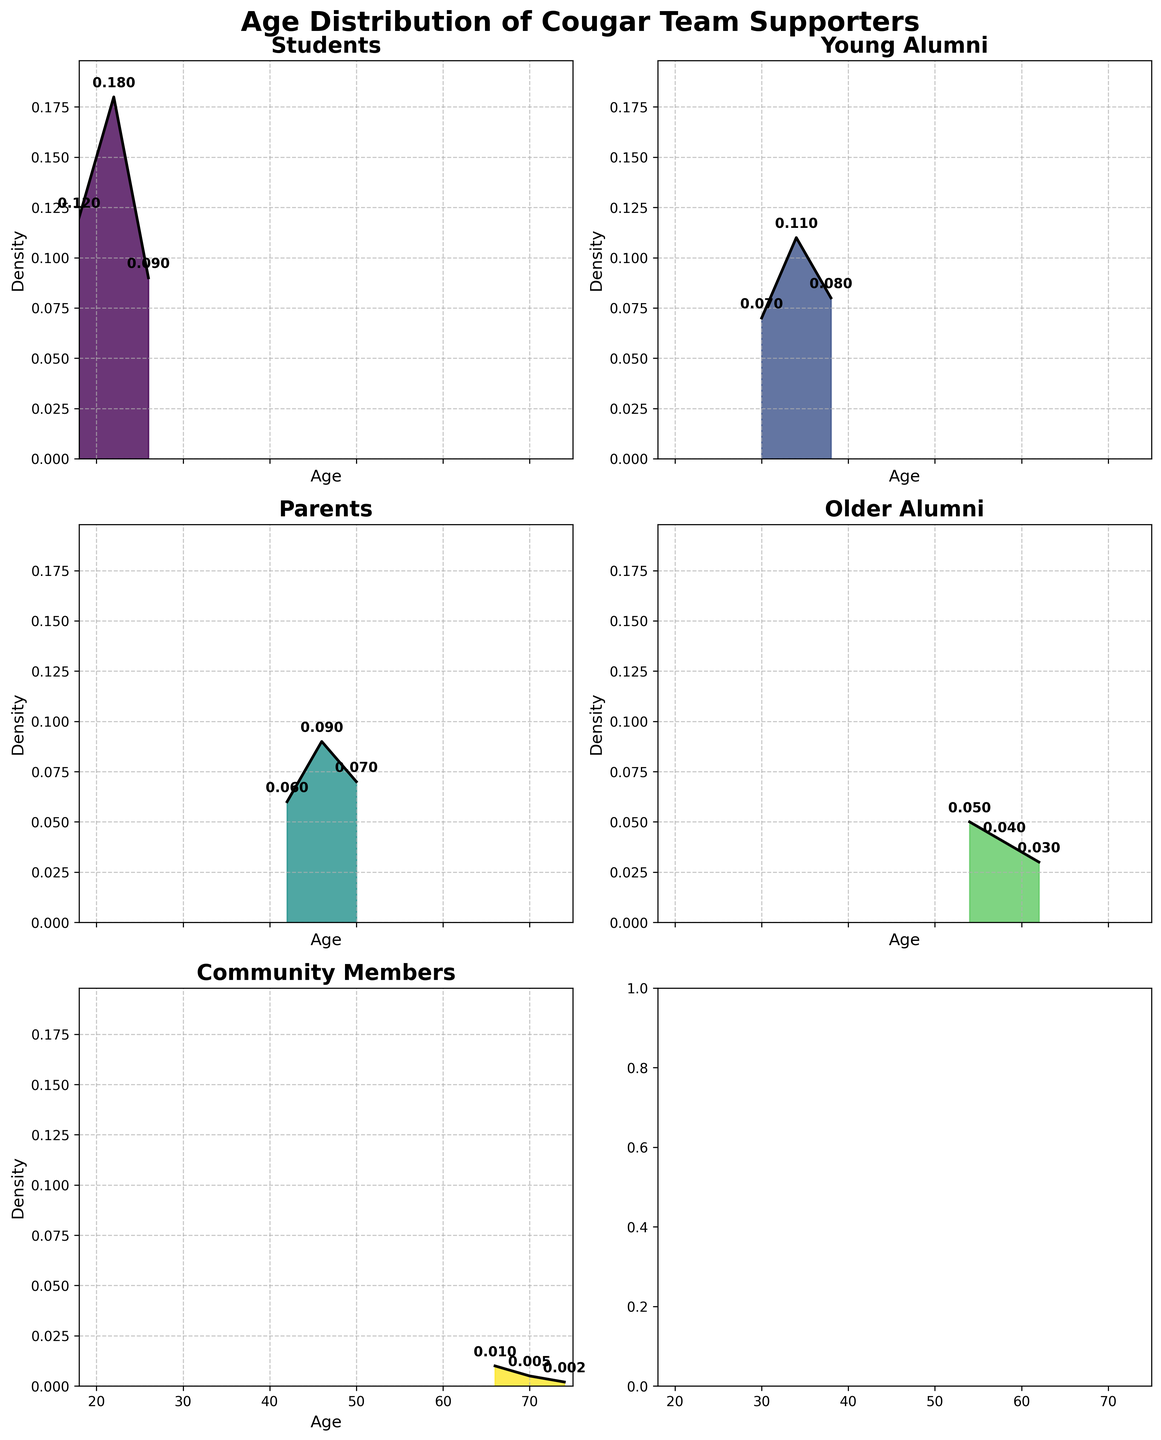What is the highest density value among Students? The peak can be seen by finding the tallest point in the Students' plot. The highest density value for Students is 0.18.
Answer: 0.18 Which category has the largest spread of ages? By looking at the x-axis spread for each subplot, the category with the largest spread of ages appears to be Community Members, ranging from 66 to 74.
Answer: Community Members Out of Students, Young Alumni, and Parents, which group has the lowest density value? Identify the lowest point in the density plots for each of these three groups. The lowest density value is 0.06 for Parents.
Answer: Parents At what age does the Young Alumni group have its highest density value? The peak of the Young Alumni plot appears around an age of 34, where the density reaches its maximum value.
Answer: 34 What range of ages shows the peak density for Parents? The density peak for Parents can be seen between ages 46. This is where the curve reaches its highest point.
Answer: 46 How much greater is the peak density of Students compared to Community Members? The peak density of Students is 0.18 and for Community Members, it is 0.01. The difference is 0.18 - 0.01 = 0.17.
Answer: 0.17 Which category has the smallest density at its peak? In each subplot, identify the smallest maximum density value. The Community Members category has the smallest peak density of 0.01.
Answer: Community Members What is the average density value for Older Alumni? Sum up the density values for Older Alumni (0.05, 0.04, 0.03) and divide by the number of values, (0.05+0.04+0.03)/3. The average density value is 0.04.
Answer: 0.04 Between what age ranges do Older Alumni have non-zero density? Older Alumni density plot starts at age 54 and ends at age 62, making the range from 54 to 62.
Answer: 54 to 62 